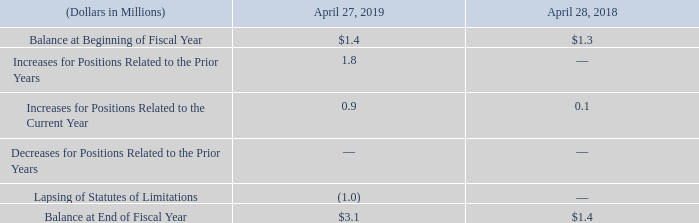Unrecognized Tax Benefits
The Company operates in multiple jurisdictions throughout the world and the income tax returns of its subsidiaries in various jurisdictions are subject to periodic examination by the tax authorities. The Company regularly assesses the status of these  examinations and the various outcomes to determine the adequacy of its provision for income taxes. The amount of gross unrecognized tax benefits totaled $3.1 million and $1.4 million at April 27, 2019 and April 28, 2018, respectively. These amounts represent the amount of unrecognized benefits that, if recognized, would favorably impact the effective tax rate if resolved in the Company’s favor.
The following table presents a reconciliation of the beginning and ending amounts of unrecognized tax benefits:
At April 27, 2019, it is not possible to reasonably estimate the expected change to the total amount of unrecognized tax benefits in the next twelve months.
The U.S. federal statute of limitations remains open for fiscal years ended on or after 2016 and for state tax purposes on or after fiscal year 2013. Tax authorities may have the ability to review and adjust net operating losses or tax credits that were generated prior to these fiscal years. In the major foreign jurisdictions, fiscal 2012 and subsequent periods remain open and subject to examination by taxing authorities.
The continuing practice of the Company is to recognize interest and penalties related to income tax matters in the provision for income taxes. The Company had $0.1 million accrued for interest and no accrual for penalties at April 27, 2019.
What was the amount of gross unrecognized tax benefits in 2019 and 2018 respectively? $3.1 million, $1.4 million. What was the accrued interest in 2019? $0.1 million. What was the Balance at Beginning of Fiscal Year in 2019?
Answer scale should be: million. 1.4. What was the change in the Balance at Beginning of Fiscal Year from 2018 to 2019?
Answer scale should be: million. 1.4 - 1.3
Answer: 0.1. What was the average Increases for Positions Related to the Prior Year for 2018 and 2019?
Answer scale should be: million. (1.8 + 0) / 2
Answer: 0.9. In which year was Balance at End of Fiscal Year less than 2.0 million? Locate and analyze balance at end of fiscal year in row 8
answer: 2018. 